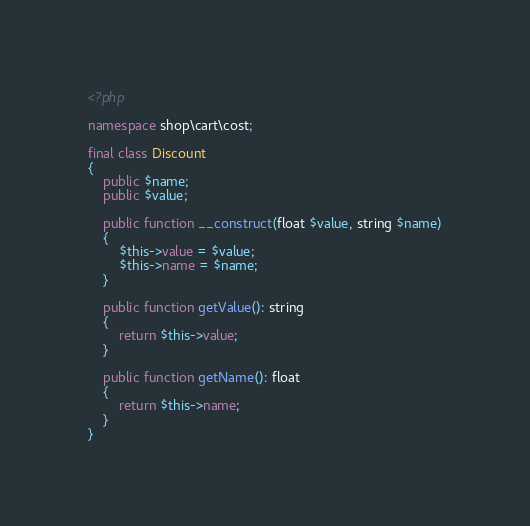<code> <loc_0><loc_0><loc_500><loc_500><_PHP_><?php

namespace shop\cart\cost;

final class Discount
{
    public $name;
    public $value;

    public function __construct(float $value, string $name)
    {
        $this->value = $value;
        $this->name = $name;
    }

    public function getValue(): string
    {
        return $this->value;
    }

    public function getName(): float
    {
        return $this->name;
    }
}</code> 